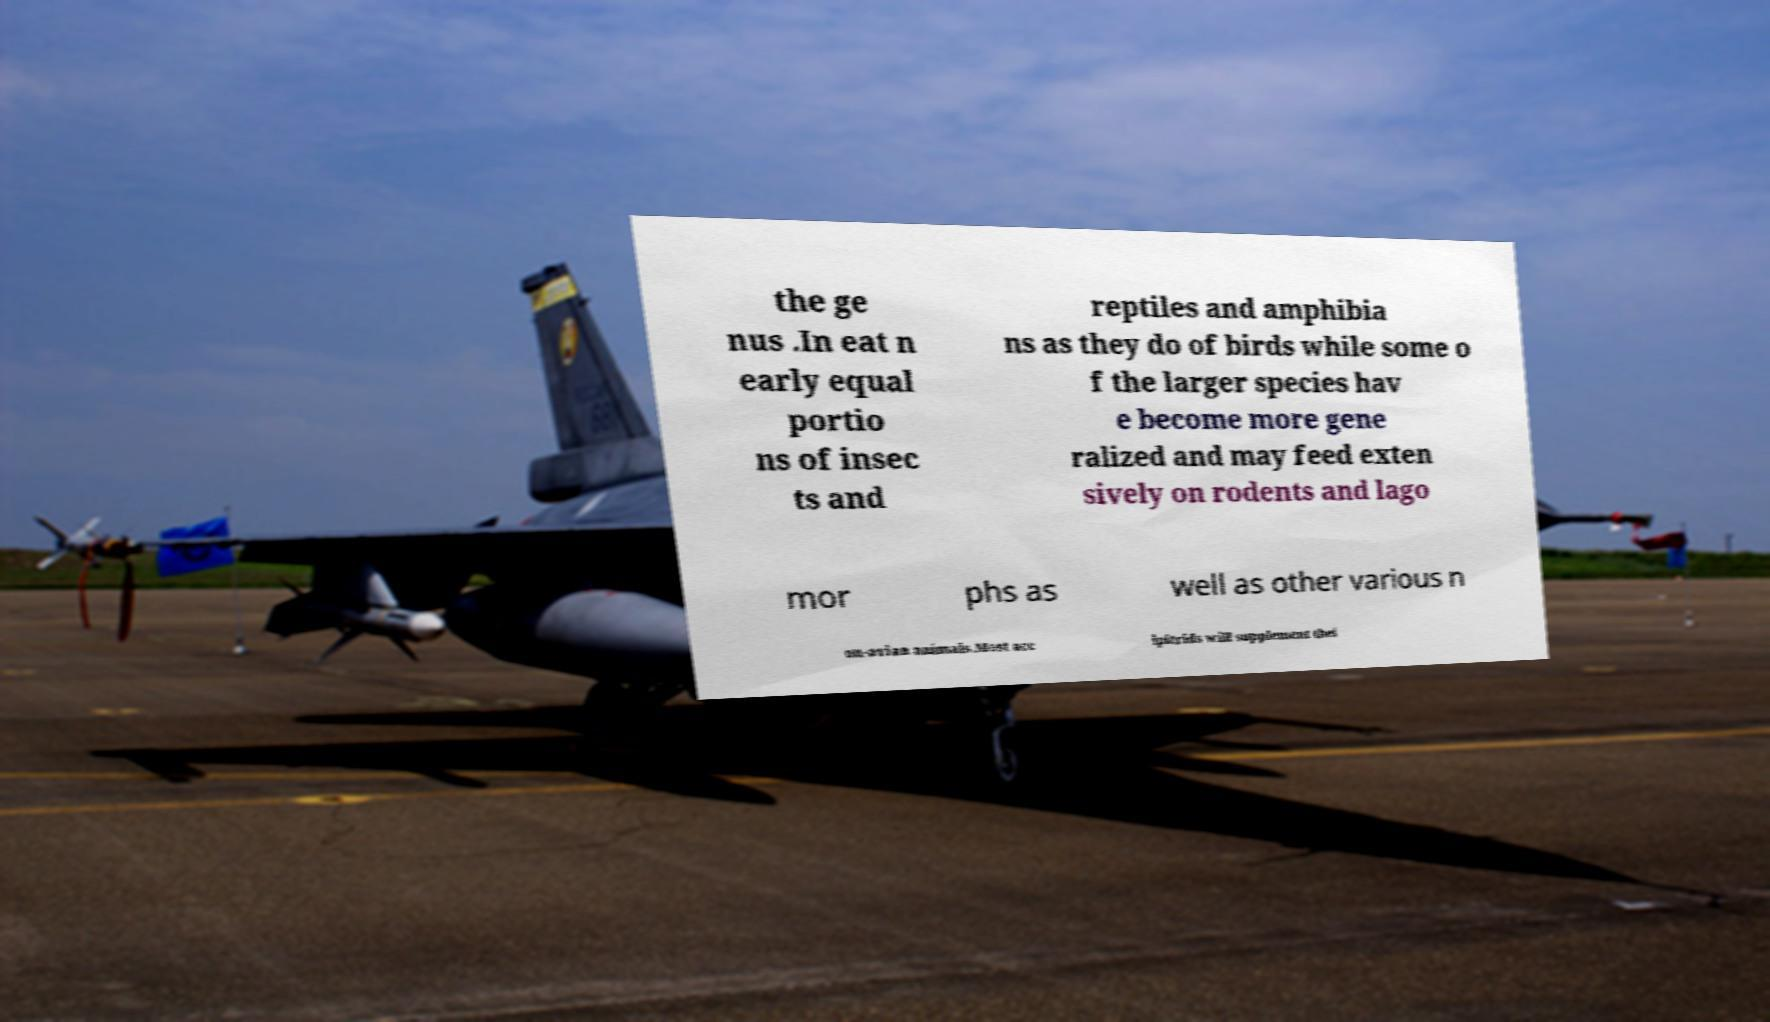Please identify and transcribe the text found in this image. the ge nus .In eat n early equal portio ns of insec ts and reptiles and amphibia ns as they do of birds while some o f the larger species hav e become more gene ralized and may feed exten sively on rodents and lago mor phs as well as other various n on-avian animals.Most acc ipitrids will supplement thei 